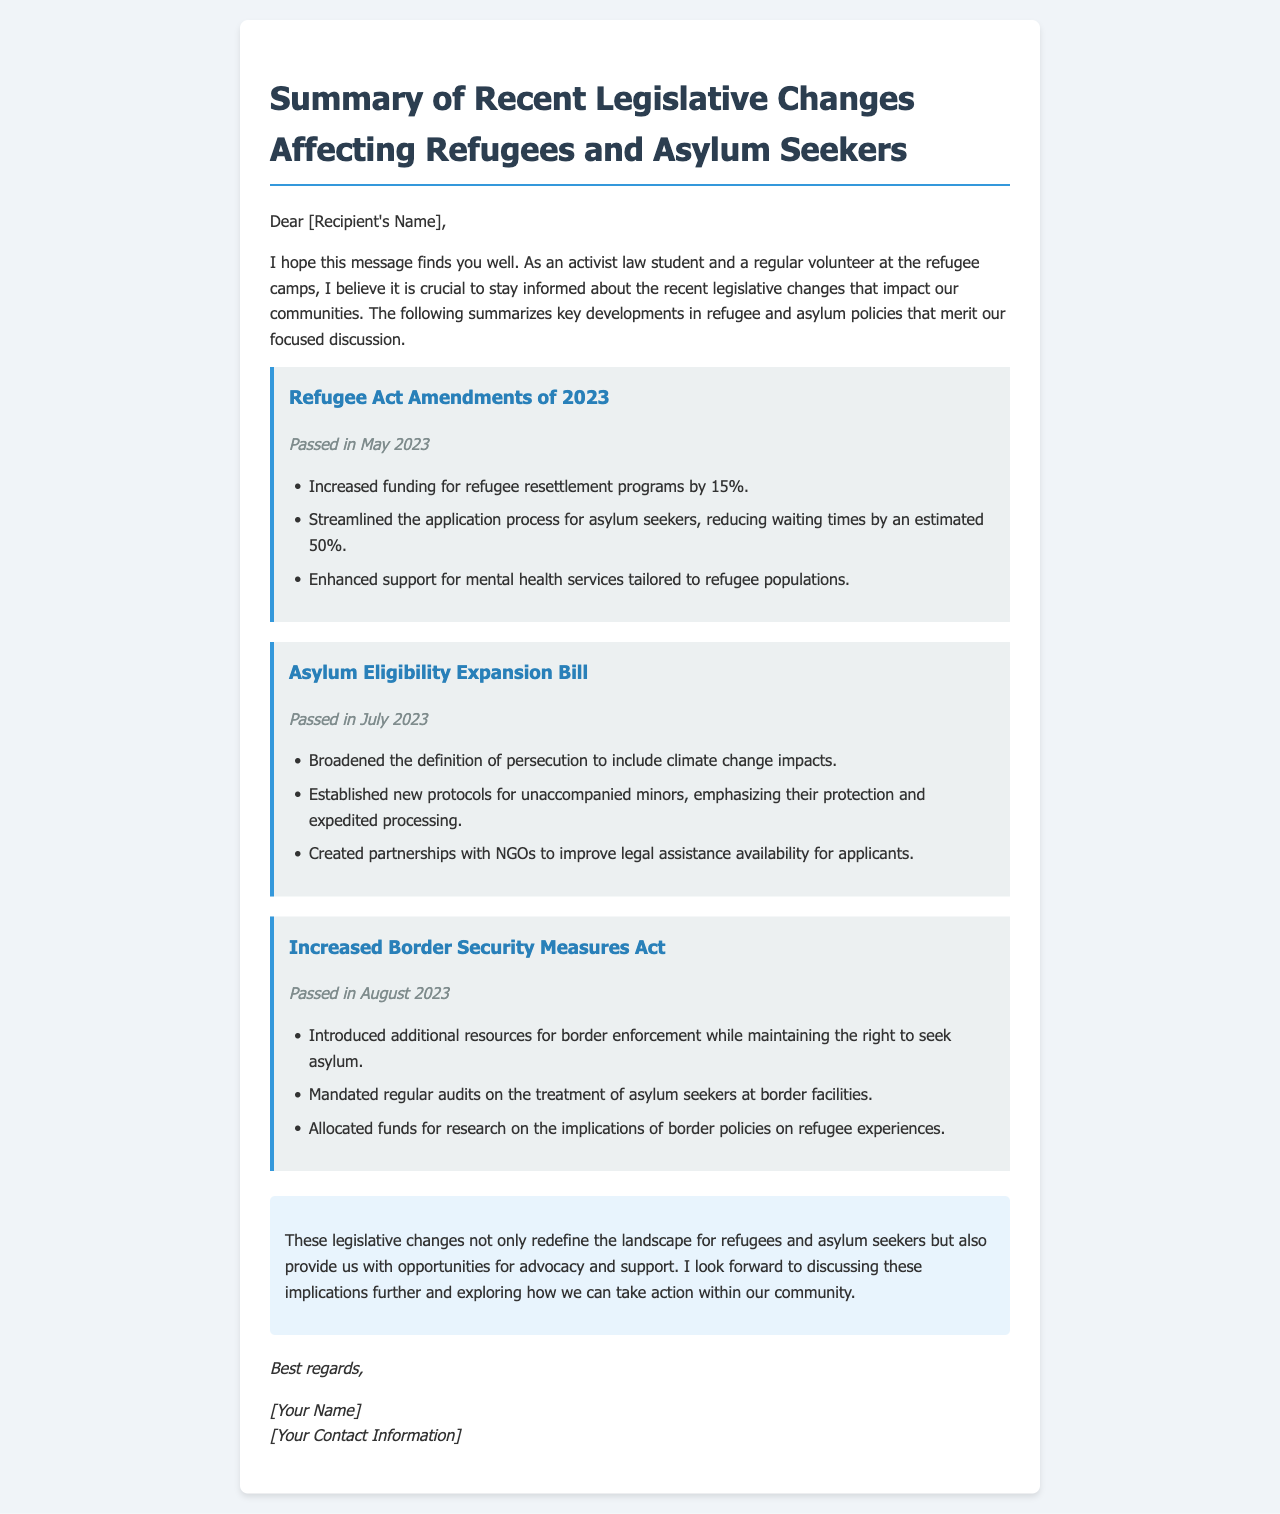What legislative change was passed in May 2023? The document states that the Refugee Act Amendments of 2023 were passed in May 2023.
Answer: Refugee Act Amendments of 2023 What is the funding increase percentage for refugee resettlement programs? The document indicates that funding for refugee resettlement programs was increased by 15%.
Answer: 15% What new protocols were established for unaccompanied minors? The document mentions that new protocols emphasize protection and expedited processing for unaccompanied minors.
Answer: Protection and expedited processing What is one reason for the new increased border security measures? The document lists that the new measures were introduced to provide additional resources for border enforcement while maintaining the right to seek asylum.
Answer: Additional resources for border enforcement When was the Asylum Eligibility Expansion Bill passed? According to the document, the Asylum Eligibility Expansion Bill was passed in July 2023.
Answer: July 2023 What does the legislative change related to climate change include? The document states that the Asylum Eligibility Expansion Bill broadened the definition of persecution to include impacts of climate change.
Answer: Climate change impacts What is a key focus of the recent mental health services support? The document notes that there is enhanced support for mental health services tailored to refugee populations.
Answer: Tailored to refugee populations What type of document is this email classified as? The context implies that it is a summary communication regarding recent legislative changes affecting refugees and asylum seekers.
Answer: Email summary 